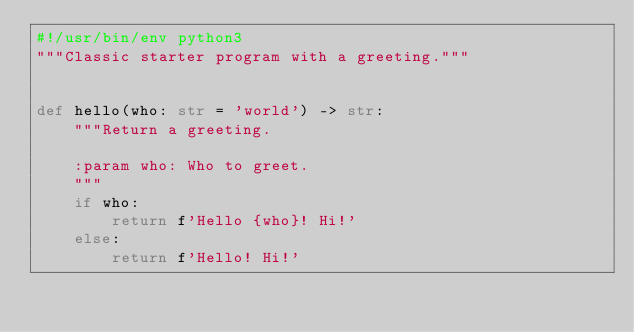Convert code to text. <code><loc_0><loc_0><loc_500><loc_500><_Python_>#!/usr/bin/env python3
"""Classic starter program with a greeting."""


def hello(who: str = 'world') -> str:
    """Return a greeting.

    :param who: Who to greet.
    """
    if who:
        return f'Hello {who}! Hi!'
    else:
        return f'Hello! Hi!'
</code> 